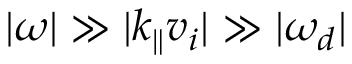<formula> <loc_0><loc_0><loc_500><loc_500>| \omega | \gg | k _ { \| } v _ { i } | \gg | \omega _ { d } |</formula> 